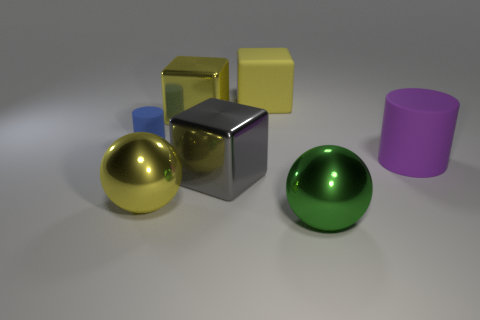Are the cylinder on the right side of the small rubber cylinder and the large block that is in front of the small rubber cylinder made of the same material?
Offer a terse response. No. How many other things have the same size as the purple thing?
Your answer should be very brief. 5. There is a ball on the right side of the gray cube; what is its material?
Provide a short and direct response. Metal. How many yellow objects have the same shape as the green metallic object?
Your response must be concise. 1. There is a big gray thing that is made of the same material as the big green sphere; what shape is it?
Give a very brief answer. Cube. What shape is the large yellow shiny thing on the left side of the large shiny object behind the cylinder behind the large purple thing?
Offer a very short reply. Sphere. Are there more big yellow metal objects than big yellow things?
Provide a succinct answer. No. What material is the large object that is the same shape as the tiny object?
Your answer should be very brief. Rubber. Does the tiny thing have the same material as the green ball?
Your response must be concise. No. Are there more big yellow objects in front of the tiny thing than large brown rubber cubes?
Give a very brief answer. Yes. 